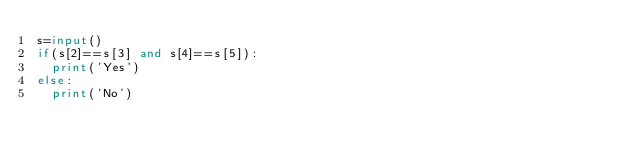Convert code to text. <code><loc_0><loc_0><loc_500><loc_500><_Python_>s=input()
if(s[2]==s[3] and s[4]==s[5]):
  print('Yes')
else:
  print('No')</code> 